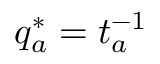<formula> <loc_0><loc_0><loc_500><loc_500>q _ { a } ^ { * } = t _ { a } ^ { - 1 }</formula> 